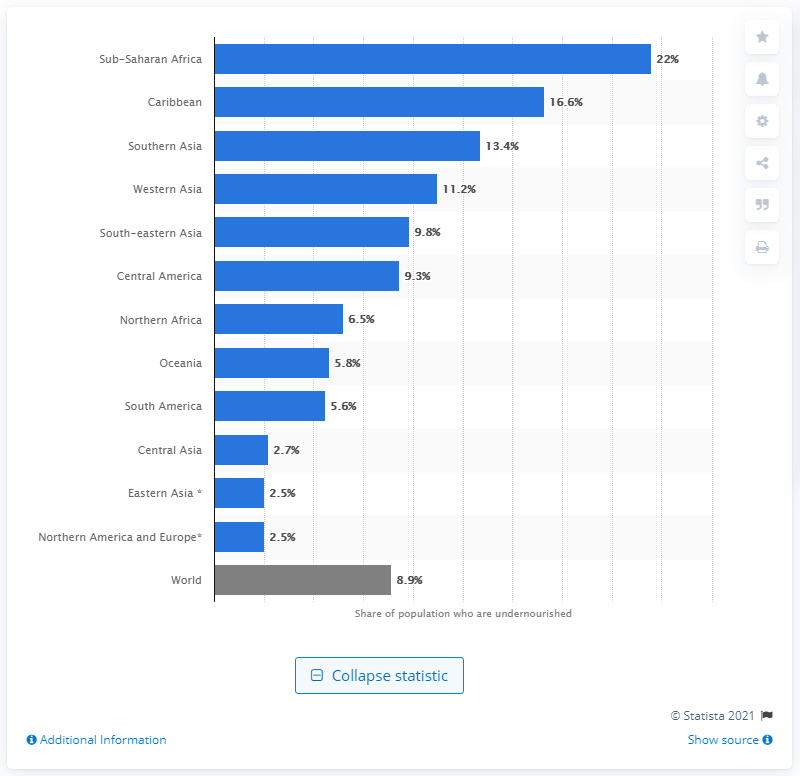Give some essential details in this illustration. According to the Global Hunger Index in 2019, Sub-Saharan Africa had the highest rate of undernourishment. 